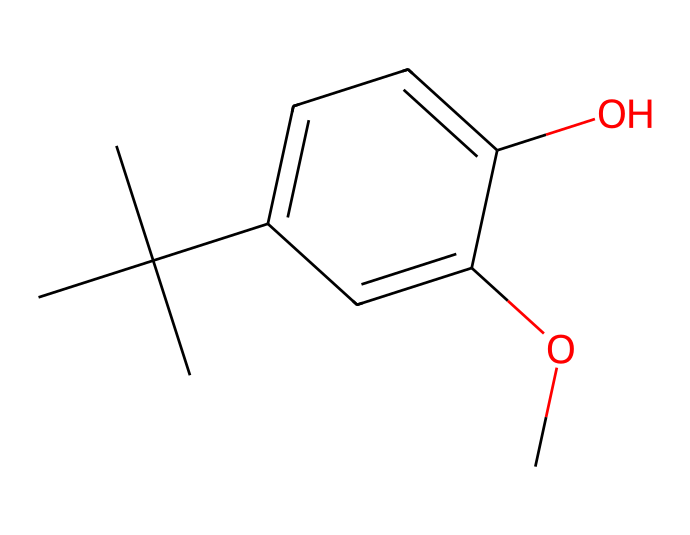What is the molecular formula of butylated hydroxyanisole (BHA)? To determine the molecular formula, count the number of carbon (C), hydrogen (H), and oxygen (O) atoms in the provided structure. There are 11 carbons, 14 hydrogens, and 2 oxygens, resulting in the formula C11H14O2.
Answer: C11H14O2 How many oxygen atoms are present in this compound? By examining the molecule, identify the functional groups and count the oxygen atoms indicated in the structure. There are two -OH (hydroxyl) and -O- (methoxy) groups contributing to a total of 2 oxygen atoms.
Answer: 2 What is the primary function of BHA in cosmetic products? BHA is commonly used as an antioxidant to prevent oxidation of compounds, which helps to maintain the product's stability and prolong its shelf life.
Answer: antioxidant Which functional groups are present in the structure of BHA? The structure contains a phenolic hydroxyl (-OH) group and a methoxy (-OCH3) group. Identifying these groups contributes to understanding the chemical's behavior and properties.
Answer: phenolic and methoxy How does the structure of BHA contribute to its antioxidant properties? The presence of the hydroxyl group in the phenolic structure allows BHA to donate electrons to free radicals, which inhibits the oxidation process. This ability to stabilize unpaired electrons is key to its antioxidant action.
Answer: by donating electrons What type of compound is BHA classified as? BHA belongs to the class of compounds known as phenolic antioxidants. The specific arrangement of its functional groups and the presence of the aromatic ring characterize it as such.
Answer: phenolic antioxidant How many rings are present in the structure of BHA? Examine the chemical for any rings or cyclic structures; in BHA’s case, there is one aromatic ring in the structure, which significantly influences its reactivity and properties.
Answer: 1 